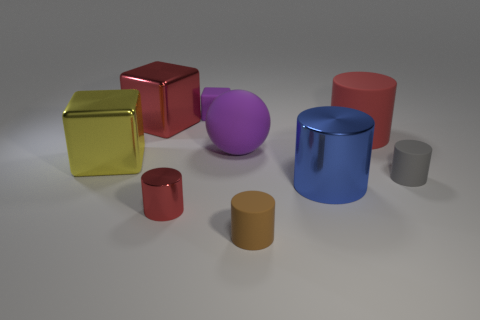Add 1 small brown things. How many objects exist? 10 Subtract all big red rubber cylinders. How many cylinders are left? 4 Subtract all red cylinders. How many cylinders are left? 3 Subtract 4 cylinders. How many cylinders are left? 1 Subtract all green blocks. How many blue balls are left? 0 Subtract all large red matte things. Subtract all metallic things. How many objects are left? 4 Add 3 brown cylinders. How many brown cylinders are left? 4 Add 4 small cyan matte spheres. How many small cyan matte spheres exist? 4 Subtract 0 cyan balls. How many objects are left? 9 Subtract all spheres. How many objects are left? 8 